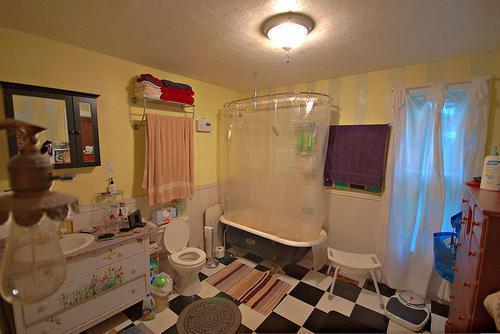How many toilets are pictured?
Give a very brief answer. 1. 